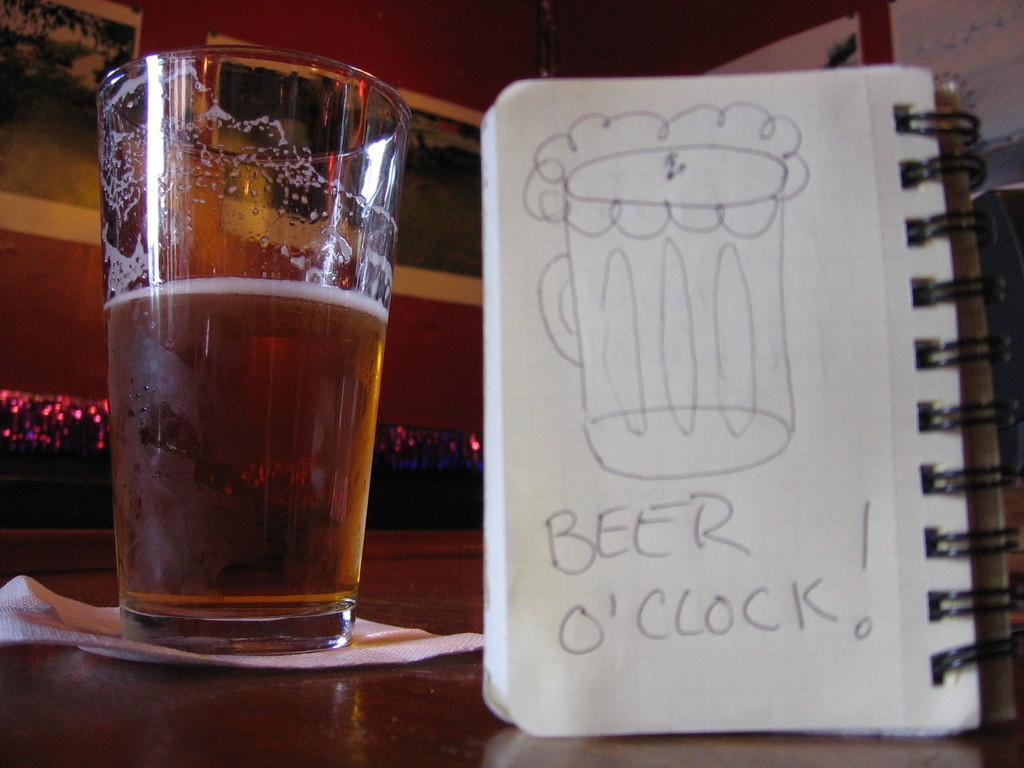<image>
Present a compact description of the photo's key features. A mug of beer with a pad of paper that reads beer o'clock! 